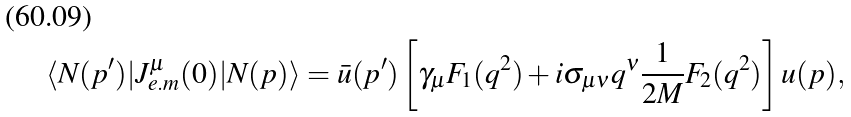<formula> <loc_0><loc_0><loc_500><loc_500>\langle N ( p ^ { \prime } ) | J ^ { \mu } _ { e . m } ( 0 ) | N ( p ) \rangle = \bar { u } ( p ^ { \prime } ) \left [ \gamma _ { \mu } F _ { 1 } ( q ^ { 2 } ) + i \sigma _ { \mu \nu } q ^ { \nu } \frac { 1 } { 2 M } F _ { 2 } ( q ^ { 2 } ) \right ] u ( p ) ,</formula> 